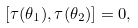<formula> <loc_0><loc_0><loc_500><loc_500>\left [ \tau ( \theta _ { 1 } ) , \tau ( \theta _ { 2 } ) \right ] = 0 ,</formula> 